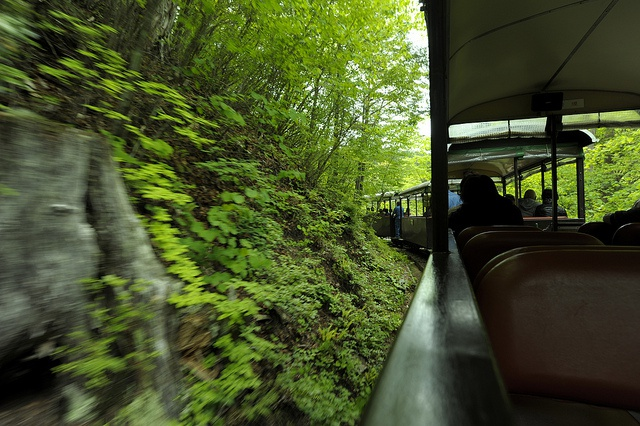Describe the objects in this image and their specific colors. I can see train in black, gray, and darkgreen tones, chair in black, gray, and darkgreen tones, people in black, darkgreen, gray, and blue tones, chair in black, gray, and darkgreen tones, and train in black, darkgreen, and olive tones in this image. 